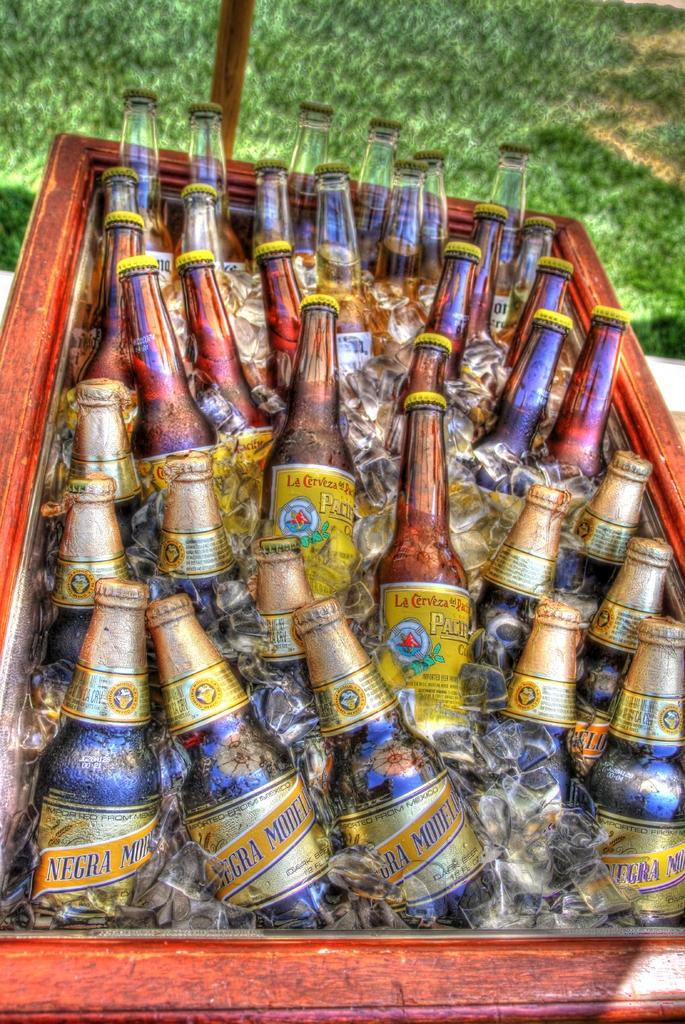What is the first word of the name of the beer on the bottom row?
Your response must be concise. Negra. What single letter do you see at the top right of the box?
Your answer should be very brief. O. 